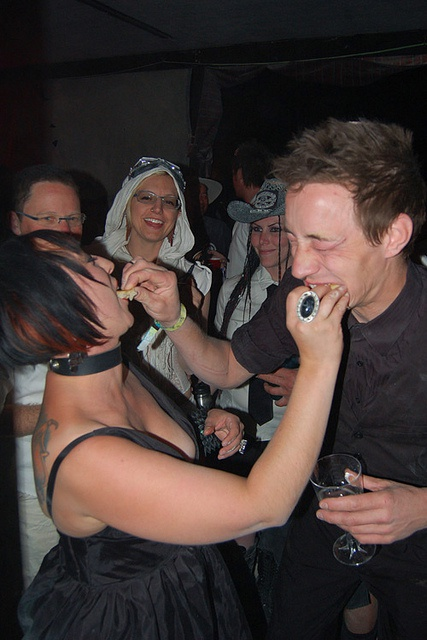Describe the objects in this image and their specific colors. I can see people in black, gray, tan, and salmon tones, people in black, gray, and salmon tones, people in black, gray, and maroon tones, people in black, gray, and brown tones, and people in black, brown, and maroon tones in this image. 